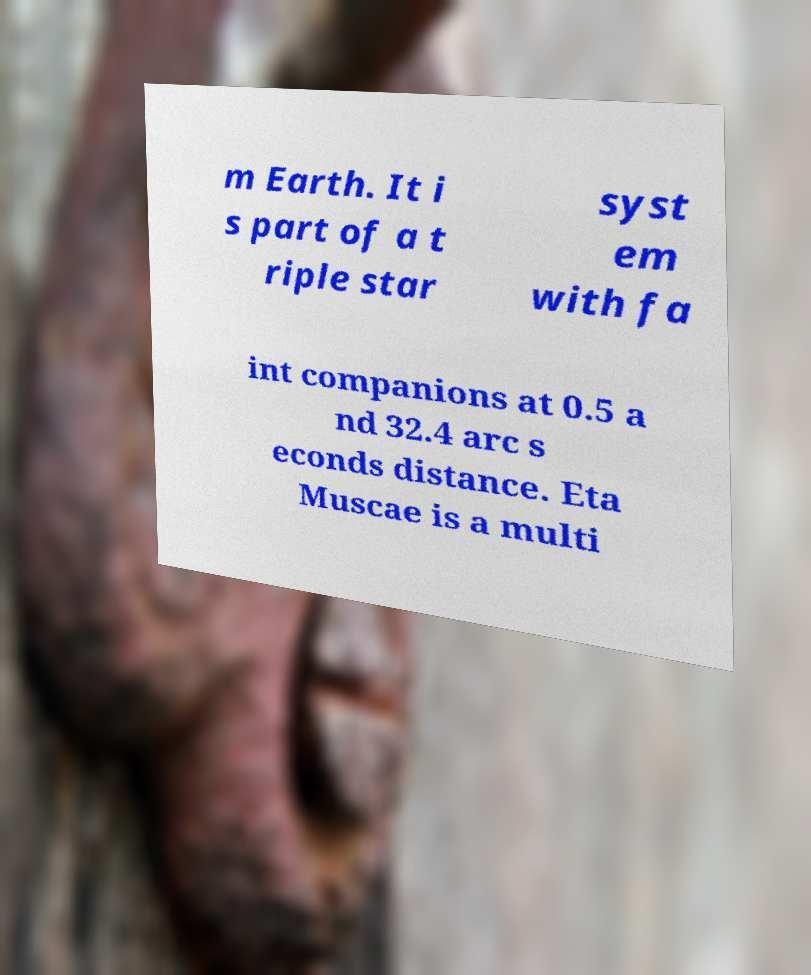Could you assist in decoding the text presented in this image and type it out clearly? m Earth. It i s part of a t riple star syst em with fa int companions at 0.5 a nd 32.4 arc s econds distance. Eta Muscae is a multi 